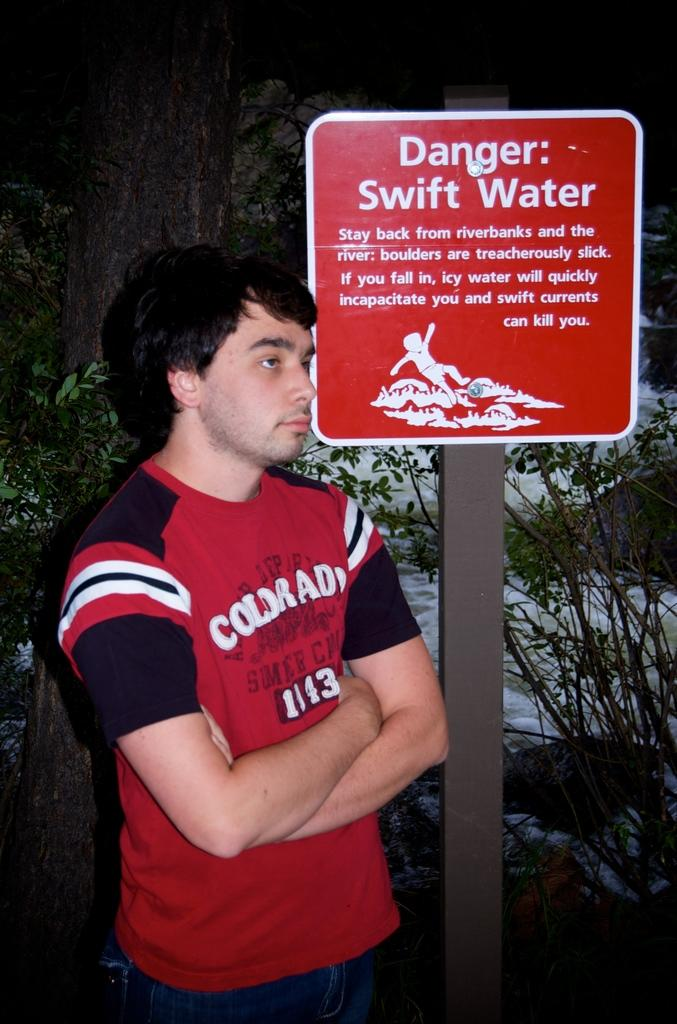<image>
Describe the image concisely. man in a red shirt standing under a danger street sign 